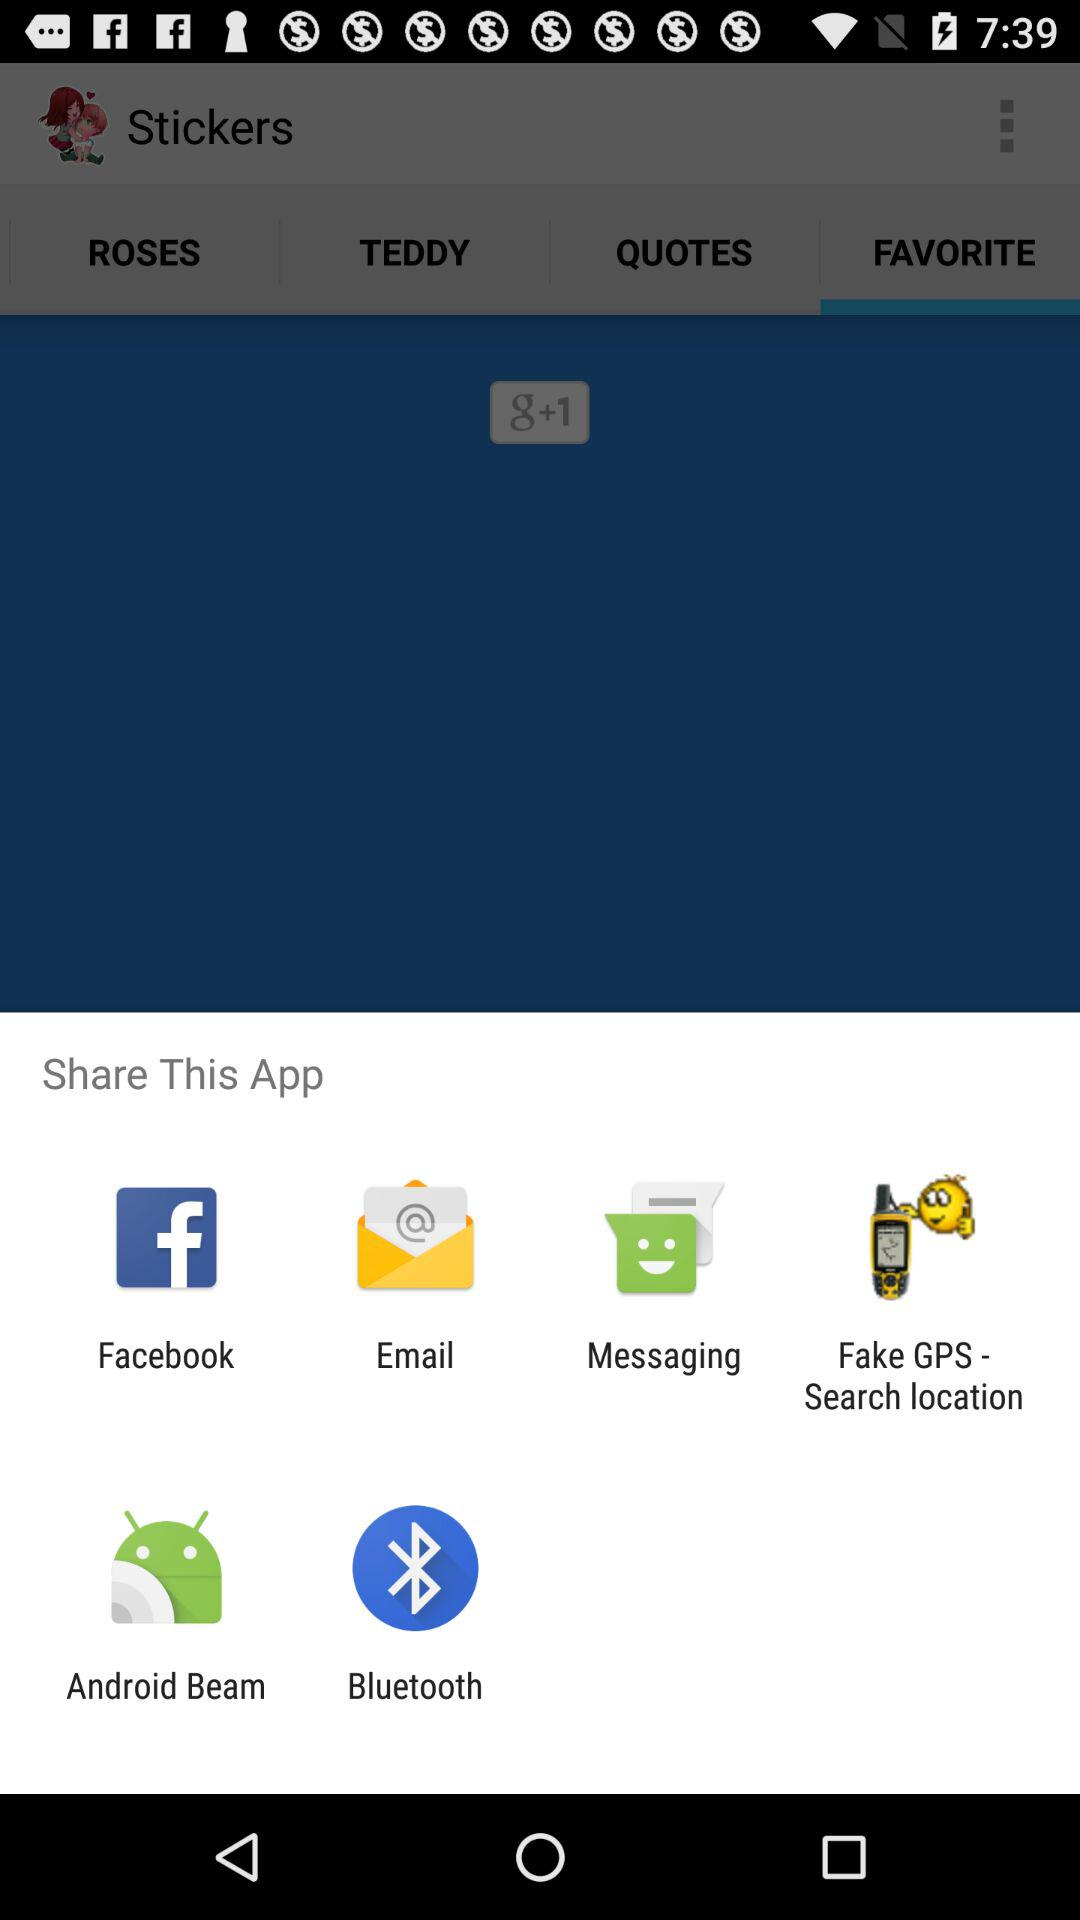How many items are in the share menu?
Answer the question using a single word or phrase. 6 